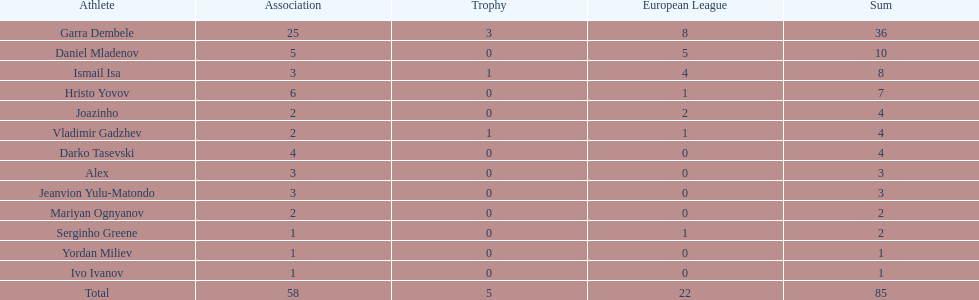What is the difference between vladimir gadzhev and yordan miliev's scores? 3. 